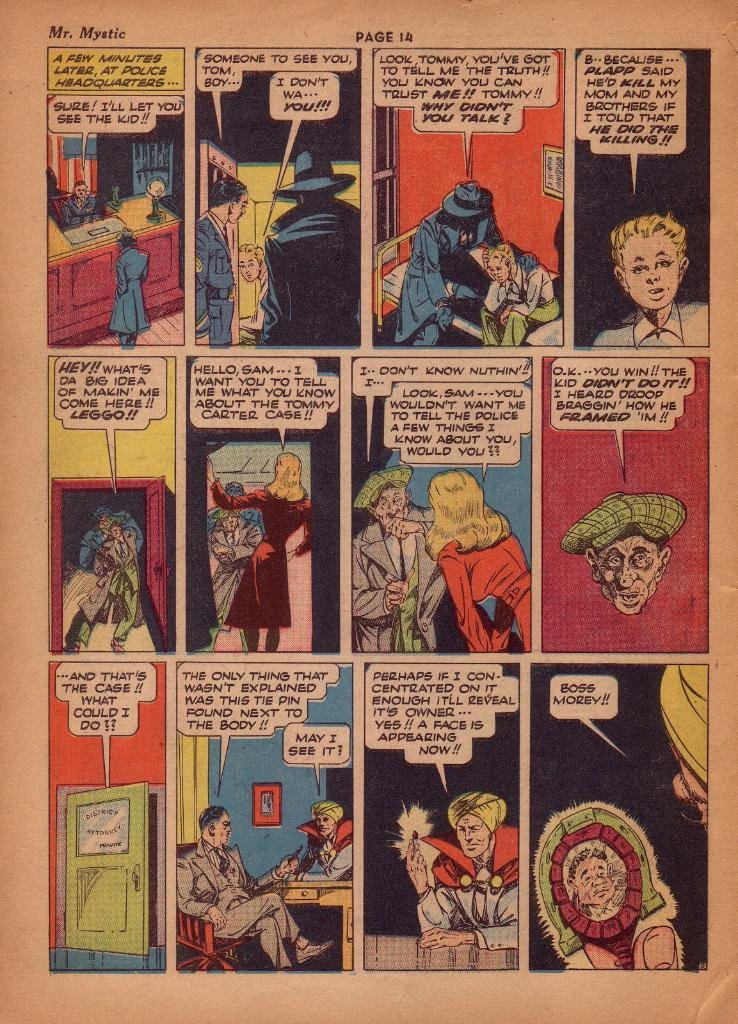What type of visual is the image? The image is a poster. What can be seen on the poster? There are depictions of people on the poster. Are there any words on the poster? Yes, there is text on the poster. What type of hair can be seen on the people depicted on the poster? There is no information about the hair of the people depicted on the poster, as the provided facts do not mention it. 